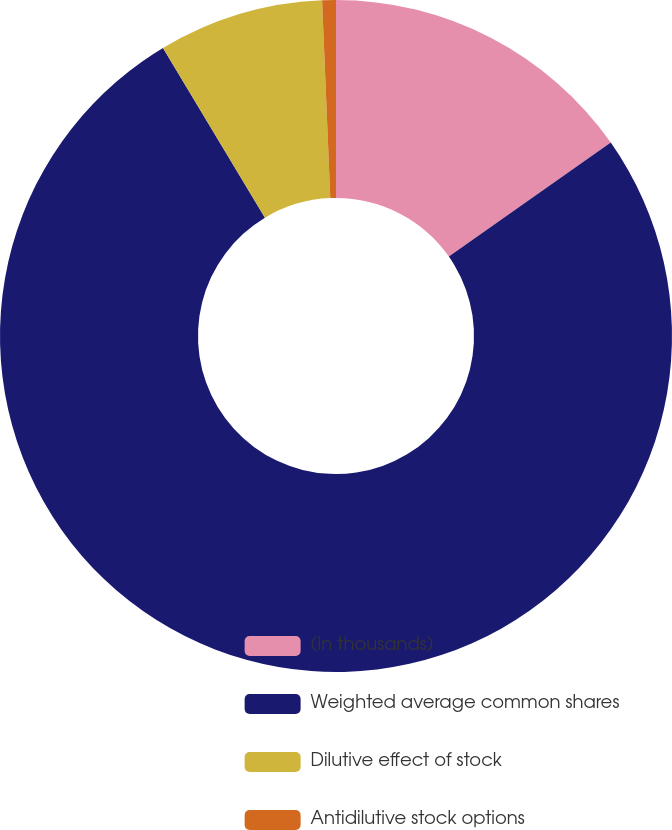<chart> <loc_0><loc_0><loc_500><loc_500><pie_chart><fcel>(In thousands)<fcel>Weighted average common shares<fcel>Dilutive effect of stock<fcel>Antidilutive stock options<nl><fcel>15.24%<fcel>76.16%<fcel>7.95%<fcel>0.66%<nl></chart> 